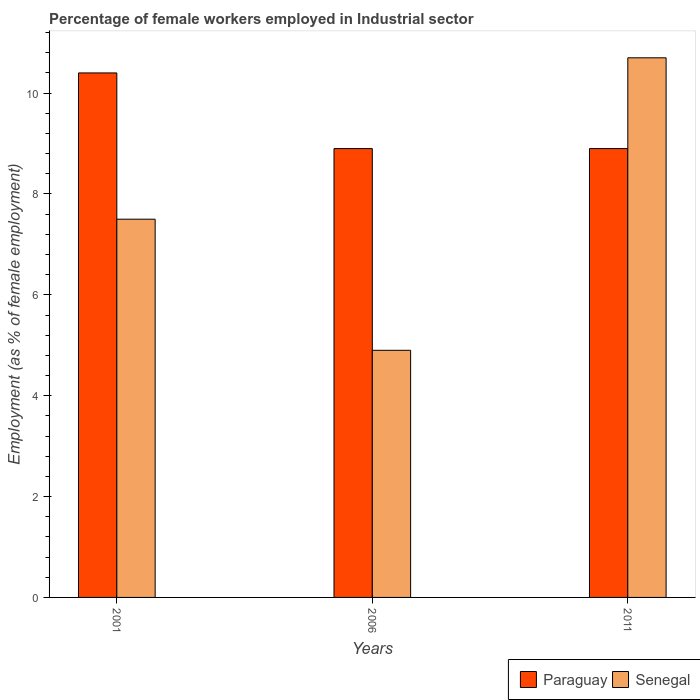How many groups of bars are there?
Your response must be concise. 3. What is the label of the 2nd group of bars from the left?
Your response must be concise. 2006. In how many cases, is the number of bars for a given year not equal to the number of legend labels?
Your response must be concise. 0. What is the percentage of females employed in Industrial sector in Paraguay in 2011?
Offer a terse response. 8.9. Across all years, what is the maximum percentage of females employed in Industrial sector in Senegal?
Ensure brevity in your answer.  10.7. Across all years, what is the minimum percentage of females employed in Industrial sector in Senegal?
Offer a terse response. 4.9. What is the total percentage of females employed in Industrial sector in Senegal in the graph?
Offer a terse response. 23.1. What is the difference between the percentage of females employed in Industrial sector in Senegal in 2001 and that in 2006?
Make the answer very short. 2.6. What is the difference between the percentage of females employed in Industrial sector in Paraguay in 2011 and the percentage of females employed in Industrial sector in Senegal in 2001?
Make the answer very short. 1.4. What is the average percentage of females employed in Industrial sector in Senegal per year?
Provide a succinct answer. 7.7. In the year 2011, what is the difference between the percentage of females employed in Industrial sector in Paraguay and percentage of females employed in Industrial sector in Senegal?
Provide a succinct answer. -1.8. What is the ratio of the percentage of females employed in Industrial sector in Senegal in 2006 to that in 2011?
Offer a very short reply. 0.46. Is the percentage of females employed in Industrial sector in Senegal in 2001 less than that in 2011?
Ensure brevity in your answer.  Yes. Is the difference between the percentage of females employed in Industrial sector in Paraguay in 2001 and 2006 greater than the difference between the percentage of females employed in Industrial sector in Senegal in 2001 and 2006?
Make the answer very short. No. What is the difference between the highest and the second highest percentage of females employed in Industrial sector in Senegal?
Give a very brief answer. 3.2. What is the difference between the highest and the lowest percentage of females employed in Industrial sector in Senegal?
Your response must be concise. 5.8. In how many years, is the percentage of females employed in Industrial sector in Paraguay greater than the average percentage of females employed in Industrial sector in Paraguay taken over all years?
Give a very brief answer. 1. Is the sum of the percentage of females employed in Industrial sector in Paraguay in 2001 and 2006 greater than the maximum percentage of females employed in Industrial sector in Senegal across all years?
Offer a very short reply. Yes. What does the 2nd bar from the left in 2011 represents?
Your answer should be compact. Senegal. What does the 2nd bar from the right in 2001 represents?
Your answer should be compact. Paraguay. Are all the bars in the graph horizontal?
Make the answer very short. No. What is the difference between two consecutive major ticks on the Y-axis?
Your response must be concise. 2. Does the graph contain grids?
Your response must be concise. No. How many legend labels are there?
Offer a terse response. 2. What is the title of the graph?
Make the answer very short. Percentage of female workers employed in Industrial sector. What is the label or title of the X-axis?
Offer a very short reply. Years. What is the label or title of the Y-axis?
Give a very brief answer. Employment (as % of female employment). What is the Employment (as % of female employment) in Paraguay in 2001?
Offer a very short reply. 10.4. What is the Employment (as % of female employment) in Senegal in 2001?
Make the answer very short. 7.5. What is the Employment (as % of female employment) of Paraguay in 2006?
Make the answer very short. 8.9. What is the Employment (as % of female employment) of Senegal in 2006?
Offer a terse response. 4.9. What is the Employment (as % of female employment) of Paraguay in 2011?
Your answer should be compact. 8.9. What is the Employment (as % of female employment) in Senegal in 2011?
Your answer should be very brief. 10.7. Across all years, what is the maximum Employment (as % of female employment) in Paraguay?
Give a very brief answer. 10.4. Across all years, what is the maximum Employment (as % of female employment) of Senegal?
Your answer should be compact. 10.7. Across all years, what is the minimum Employment (as % of female employment) of Paraguay?
Provide a short and direct response. 8.9. Across all years, what is the minimum Employment (as % of female employment) of Senegal?
Ensure brevity in your answer.  4.9. What is the total Employment (as % of female employment) of Paraguay in the graph?
Offer a terse response. 28.2. What is the total Employment (as % of female employment) in Senegal in the graph?
Keep it short and to the point. 23.1. What is the difference between the Employment (as % of female employment) of Paraguay in 2001 and that in 2011?
Keep it short and to the point. 1.5. What is the difference between the Employment (as % of female employment) of Senegal in 2006 and that in 2011?
Your response must be concise. -5.8. What is the average Employment (as % of female employment) in Paraguay per year?
Your answer should be very brief. 9.4. What is the average Employment (as % of female employment) of Senegal per year?
Your answer should be very brief. 7.7. In the year 2006, what is the difference between the Employment (as % of female employment) in Paraguay and Employment (as % of female employment) in Senegal?
Make the answer very short. 4. In the year 2011, what is the difference between the Employment (as % of female employment) in Paraguay and Employment (as % of female employment) in Senegal?
Provide a succinct answer. -1.8. What is the ratio of the Employment (as % of female employment) of Paraguay in 2001 to that in 2006?
Your answer should be very brief. 1.17. What is the ratio of the Employment (as % of female employment) of Senegal in 2001 to that in 2006?
Keep it short and to the point. 1.53. What is the ratio of the Employment (as % of female employment) of Paraguay in 2001 to that in 2011?
Offer a terse response. 1.17. What is the ratio of the Employment (as % of female employment) of Senegal in 2001 to that in 2011?
Your answer should be very brief. 0.7. What is the ratio of the Employment (as % of female employment) of Senegal in 2006 to that in 2011?
Keep it short and to the point. 0.46. What is the difference between the highest and the second highest Employment (as % of female employment) of Paraguay?
Provide a short and direct response. 1.5. What is the difference between the highest and the second highest Employment (as % of female employment) in Senegal?
Ensure brevity in your answer.  3.2. 